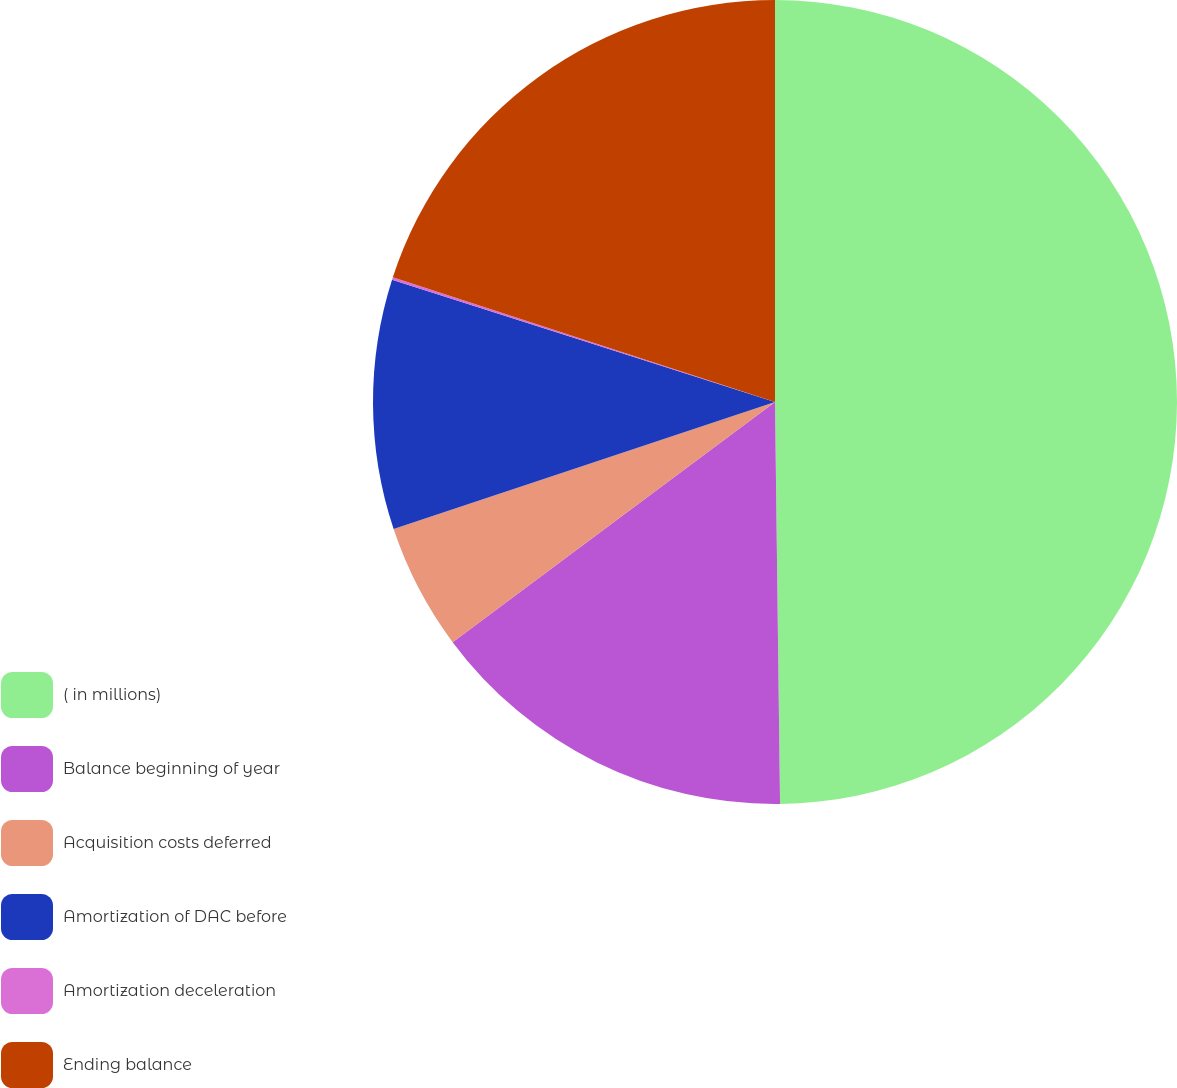Convert chart. <chart><loc_0><loc_0><loc_500><loc_500><pie_chart><fcel>( in millions)<fcel>Balance beginning of year<fcel>Acquisition costs deferred<fcel>Amortization of DAC before<fcel>Amortization deceleration<fcel>Ending balance<nl><fcel>49.8%<fcel>15.01%<fcel>5.07%<fcel>10.04%<fcel>0.1%<fcel>19.98%<nl></chart> 